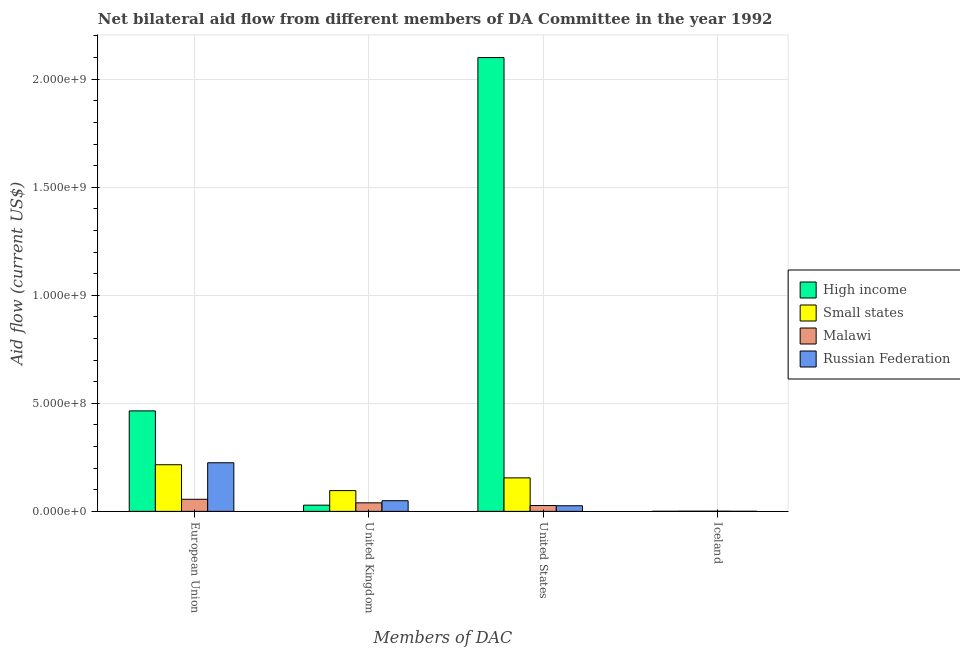How many groups of bars are there?
Keep it short and to the point. 4. Are the number of bars per tick equal to the number of legend labels?
Keep it short and to the point. Yes. What is the label of the 2nd group of bars from the left?
Your response must be concise. United Kingdom. What is the amount of aid given by eu in Malawi?
Offer a terse response. 5.60e+07. Across all countries, what is the maximum amount of aid given by uk?
Keep it short and to the point. 9.61e+07. Across all countries, what is the minimum amount of aid given by eu?
Provide a short and direct response. 5.60e+07. In which country was the amount of aid given by eu minimum?
Offer a terse response. Malawi. What is the total amount of aid given by iceland in the graph?
Ensure brevity in your answer.  2.15e+06. What is the difference between the amount of aid given by us in High income and that in Russian Federation?
Provide a short and direct response. 2.07e+09. What is the difference between the amount of aid given by iceland in High income and the amount of aid given by uk in Small states?
Your response must be concise. -9.58e+07. What is the average amount of aid given by eu per country?
Make the answer very short. 2.40e+08. What is the difference between the amount of aid given by iceland and amount of aid given by eu in Small states?
Offer a terse response. -2.15e+08. What is the ratio of the amount of aid given by iceland in Malawi to that in High income?
Your answer should be compact. 2.5. What is the difference between the highest and the second highest amount of aid given by eu?
Offer a terse response. 2.40e+08. What is the difference between the highest and the lowest amount of aid given by iceland?
Your response must be concise. 5.00e+05. What does the 2nd bar from the left in European Union represents?
Offer a very short reply. Small states. Is it the case that in every country, the sum of the amount of aid given by eu and amount of aid given by uk is greater than the amount of aid given by us?
Your response must be concise. No. What is the difference between two consecutive major ticks on the Y-axis?
Give a very brief answer. 5.00e+08. What is the title of the graph?
Make the answer very short. Net bilateral aid flow from different members of DA Committee in the year 1992. What is the label or title of the X-axis?
Offer a terse response. Members of DAC. What is the Aid flow (current US$) of High income in European Union?
Your response must be concise. 4.65e+08. What is the Aid flow (current US$) of Small states in European Union?
Offer a very short reply. 2.16e+08. What is the Aid flow (current US$) of Malawi in European Union?
Keep it short and to the point. 5.60e+07. What is the Aid flow (current US$) of Russian Federation in European Union?
Give a very brief answer. 2.25e+08. What is the Aid flow (current US$) in High income in United Kingdom?
Keep it short and to the point. 2.87e+07. What is the Aid flow (current US$) in Small states in United Kingdom?
Ensure brevity in your answer.  9.61e+07. What is the Aid flow (current US$) in Malawi in United Kingdom?
Make the answer very short. 3.95e+07. What is the Aid flow (current US$) of Russian Federation in United Kingdom?
Your answer should be compact. 4.93e+07. What is the Aid flow (current US$) in High income in United States?
Make the answer very short. 2.10e+09. What is the Aid flow (current US$) in Small states in United States?
Your answer should be very brief. 1.55e+08. What is the Aid flow (current US$) in Malawi in United States?
Keep it short and to the point. 2.70e+07. What is the Aid flow (current US$) in Russian Federation in United States?
Make the answer very short. 2.60e+07. What is the Aid flow (current US$) in Malawi in Iceland?
Your answer should be compact. 7.50e+05. Across all Members of DAC, what is the maximum Aid flow (current US$) in High income?
Your answer should be very brief. 2.10e+09. Across all Members of DAC, what is the maximum Aid flow (current US$) of Small states?
Make the answer very short. 2.16e+08. Across all Members of DAC, what is the maximum Aid flow (current US$) in Malawi?
Provide a succinct answer. 5.60e+07. Across all Members of DAC, what is the maximum Aid flow (current US$) in Russian Federation?
Provide a succinct answer. 2.25e+08. Across all Members of DAC, what is the minimum Aid flow (current US$) of Malawi?
Provide a succinct answer. 7.50e+05. Across all Members of DAC, what is the minimum Aid flow (current US$) in Russian Federation?
Your answer should be compact. 3.00e+05. What is the total Aid flow (current US$) in High income in the graph?
Provide a short and direct response. 2.59e+09. What is the total Aid flow (current US$) in Small states in the graph?
Provide a succinct answer. 4.68e+08. What is the total Aid flow (current US$) in Malawi in the graph?
Give a very brief answer. 1.23e+08. What is the total Aid flow (current US$) of Russian Federation in the graph?
Offer a very short reply. 3.01e+08. What is the difference between the Aid flow (current US$) of High income in European Union and that in United Kingdom?
Offer a very short reply. 4.36e+08. What is the difference between the Aid flow (current US$) of Small states in European Union and that in United Kingdom?
Offer a terse response. 1.20e+08. What is the difference between the Aid flow (current US$) of Malawi in European Union and that in United Kingdom?
Ensure brevity in your answer.  1.65e+07. What is the difference between the Aid flow (current US$) in Russian Federation in European Union and that in United Kingdom?
Provide a short and direct response. 1.76e+08. What is the difference between the Aid flow (current US$) of High income in European Union and that in United States?
Ensure brevity in your answer.  -1.64e+09. What is the difference between the Aid flow (current US$) of Small states in European Union and that in United States?
Make the answer very short. 6.07e+07. What is the difference between the Aid flow (current US$) in Malawi in European Union and that in United States?
Make the answer very short. 2.90e+07. What is the difference between the Aid flow (current US$) of Russian Federation in European Union and that in United States?
Give a very brief answer. 1.99e+08. What is the difference between the Aid flow (current US$) of High income in European Union and that in Iceland?
Provide a short and direct response. 4.65e+08. What is the difference between the Aid flow (current US$) in Small states in European Union and that in Iceland?
Provide a short and direct response. 2.15e+08. What is the difference between the Aid flow (current US$) in Malawi in European Union and that in Iceland?
Ensure brevity in your answer.  5.52e+07. What is the difference between the Aid flow (current US$) in Russian Federation in European Union and that in Iceland?
Offer a very short reply. 2.25e+08. What is the difference between the Aid flow (current US$) in High income in United Kingdom and that in United States?
Keep it short and to the point. -2.07e+09. What is the difference between the Aid flow (current US$) in Small states in United Kingdom and that in United States?
Provide a succinct answer. -5.89e+07. What is the difference between the Aid flow (current US$) in Malawi in United Kingdom and that in United States?
Your answer should be compact. 1.25e+07. What is the difference between the Aid flow (current US$) of Russian Federation in United Kingdom and that in United States?
Your answer should be very brief. 2.33e+07. What is the difference between the Aid flow (current US$) of High income in United Kingdom and that in Iceland?
Provide a succinct answer. 2.84e+07. What is the difference between the Aid flow (current US$) of Small states in United Kingdom and that in Iceland?
Offer a terse response. 9.53e+07. What is the difference between the Aid flow (current US$) of Malawi in United Kingdom and that in Iceland?
Make the answer very short. 3.87e+07. What is the difference between the Aid flow (current US$) of Russian Federation in United Kingdom and that in Iceland?
Your response must be concise. 4.90e+07. What is the difference between the Aid flow (current US$) in High income in United States and that in Iceland?
Your answer should be very brief. 2.10e+09. What is the difference between the Aid flow (current US$) in Small states in United States and that in Iceland?
Your answer should be compact. 1.54e+08. What is the difference between the Aid flow (current US$) of Malawi in United States and that in Iceland?
Provide a succinct answer. 2.62e+07. What is the difference between the Aid flow (current US$) in Russian Federation in United States and that in Iceland?
Offer a very short reply. 2.57e+07. What is the difference between the Aid flow (current US$) of High income in European Union and the Aid flow (current US$) of Small states in United Kingdom?
Offer a very short reply. 3.69e+08. What is the difference between the Aid flow (current US$) in High income in European Union and the Aid flow (current US$) in Malawi in United Kingdom?
Ensure brevity in your answer.  4.26e+08. What is the difference between the Aid flow (current US$) of High income in European Union and the Aid flow (current US$) of Russian Federation in United Kingdom?
Your answer should be very brief. 4.16e+08. What is the difference between the Aid flow (current US$) in Small states in European Union and the Aid flow (current US$) in Malawi in United Kingdom?
Offer a terse response. 1.76e+08. What is the difference between the Aid flow (current US$) of Small states in European Union and the Aid flow (current US$) of Russian Federation in United Kingdom?
Provide a short and direct response. 1.66e+08. What is the difference between the Aid flow (current US$) in Malawi in European Union and the Aid flow (current US$) in Russian Federation in United Kingdom?
Keep it short and to the point. 6.64e+06. What is the difference between the Aid flow (current US$) in High income in European Union and the Aid flow (current US$) in Small states in United States?
Your answer should be compact. 3.10e+08. What is the difference between the Aid flow (current US$) in High income in European Union and the Aid flow (current US$) in Malawi in United States?
Offer a terse response. 4.38e+08. What is the difference between the Aid flow (current US$) in High income in European Union and the Aid flow (current US$) in Russian Federation in United States?
Provide a short and direct response. 4.39e+08. What is the difference between the Aid flow (current US$) in Small states in European Union and the Aid flow (current US$) in Malawi in United States?
Offer a very short reply. 1.89e+08. What is the difference between the Aid flow (current US$) of Small states in European Union and the Aid flow (current US$) of Russian Federation in United States?
Keep it short and to the point. 1.90e+08. What is the difference between the Aid flow (current US$) in Malawi in European Union and the Aid flow (current US$) in Russian Federation in United States?
Make the answer very short. 3.00e+07. What is the difference between the Aid flow (current US$) in High income in European Union and the Aid flow (current US$) in Small states in Iceland?
Your answer should be compact. 4.64e+08. What is the difference between the Aid flow (current US$) of High income in European Union and the Aid flow (current US$) of Malawi in Iceland?
Your answer should be compact. 4.64e+08. What is the difference between the Aid flow (current US$) in High income in European Union and the Aid flow (current US$) in Russian Federation in Iceland?
Give a very brief answer. 4.65e+08. What is the difference between the Aid flow (current US$) in Small states in European Union and the Aid flow (current US$) in Malawi in Iceland?
Make the answer very short. 2.15e+08. What is the difference between the Aid flow (current US$) in Small states in European Union and the Aid flow (current US$) in Russian Federation in Iceland?
Provide a short and direct response. 2.15e+08. What is the difference between the Aid flow (current US$) in Malawi in European Union and the Aid flow (current US$) in Russian Federation in Iceland?
Your answer should be very brief. 5.57e+07. What is the difference between the Aid flow (current US$) in High income in United Kingdom and the Aid flow (current US$) in Small states in United States?
Offer a terse response. -1.26e+08. What is the difference between the Aid flow (current US$) in High income in United Kingdom and the Aid flow (current US$) in Malawi in United States?
Provide a short and direct response. 1.67e+06. What is the difference between the Aid flow (current US$) of High income in United Kingdom and the Aid flow (current US$) of Russian Federation in United States?
Make the answer very short. 2.67e+06. What is the difference between the Aid flow (current US$) of Small states in United Kingdom and the Aid flow (current US$) of Malawi in United States?
Your answer should be compact. 6.91e+07. What is the difference between the Aid flow (current US$) of Small states in United Kingdom and the Aid flow (current US$) of Russian Federation in United States?
Offer a terse response. 7.01e+07. What is the difference between the Aid flow (current US$) of Malawi in United Kingdom and the Aid flow (current US$) of Russian Federation in United States?
Provide a succinct answer. 1.35e+07. What is the difference between the Aid flow (current US$) of High income in United Kingdom and the Aid flow (current US$) of Small states in Iceland?
Provide a succinct answer. 2.79e+07. What is the difference between the Aid flow (current US$) in High income in United Kingdom and the Aid flow (current US$) in Malawi in Iceland?
Offer a very short reply. 2.79e+07. What is the difference between the Aid flow (current US$) of High income in United Kingdom and the Aid flow (current US$) of Russian Federation in Iceland?
Provide a succinct answer. 2.84e+07. What is the difference between the Aid flow (current US$) in Small states in United Kingdom and the Aid flow (current US$) in Malawi in Iceland?
Provide a succinct answer. 9.54e+07. What is the difference between the Aid flow (current US$) of Small states in United Kingdom and the Aid flow (current US$) of Russian Federation in Iceland?
Ensure brevity in your answer.  9.58e+07. What is the difference between the Aid flow (current US$) of Malawi in United Kingdom and the Aid flow (current US$) of Russian Federation in Iceland?
Your response must be concise. 3.92e+07. What is the difference between the Aid flow (current US$) of High income in United States and the Aid flow (current US$) of Small states in Iceland?
Keep it short and to the point. 2.10e+09. What is the difference between the Aid flow (current US$) of High income in United States and the Aid flow (current US$) of Malawi in Iceland?
Provide a short and direct response. 2.10e+09. What is the difference between the Aid flow (current US$) of High income in United States and the Aid flow (current US$) of Russian Federation in Iceland?
Give a very brief answer. 2.10e+09. What is the difference between the Aid flow (current US$) in Small states in United States and the Aid flow (current US$) in Malawi in Iceland?
Offer a terse response. 1.54e+08. What is the difference between the Aid flow (current US$) in Small states in United States and the Aid flow (current US$) in Russian Federation in Iceland?
Make the answer very short. 1.55e+08. What is the difference between the Aid flow (current US$) in Malawi in United States and the Aid flow (current US$) in Russian Federation in Iceland?
Your answer should be compact. 2.67e+07. What is the average Aid flow (current US$) of High income per Members of DAC?
Your answer should be very brief. 6.48e+08. What is the average Aid flow (current US$) in Small states per Members of DAC?
Ensure brevity in your answer.  1.17e+08. What is the average Aid flow (current US$) in Malawi per Members of DAC?
Provide a succinct answer. 3.08e+07. What is the average Aid flow (current US$) of Russian Federation per Members of DAC?
Your answer should be very brief. 7.51e+07. What is the difference between the Aid flow (current US$) of High income and Aid flow (current US$) of Small states in European Union?
Keep it short and to the point. 2.49e+08. What is the difference between the Aid flow (current US$) of High income and Aid flow (current US$) of Malawi in European Union?
Your answer should be compact. 4.09e+08. What is the difference between the Aid flow (current US$) of High income and Aid flow (current US$) of Russian Federation in European Union?
Make the answer very short. 2.40e+08. What is the difference between the Aid flow (current US$) in Small states and Aid flow (current US$) in Malawi in European Union?
Ensure brevity in your answer.  1.60e+08. What is the difference between the Aid flow (current US$) in Small states and Aid flow (current US$) in Russian Federation in European Union?
Offer a very short reply. -9.24e+06. What is the difference between the Aid flow (current US$) in Malawi and Aid flow (current US$) in Russian Federation in European Union?
Offer a very short reply. -1.69e+08. What is the difference between the Aid flow (current US$) in High income and Aid flow (current US$) in Small states in United Kingdom?
Provide a short and direct response. -6.74e+07. What is the difference between the Aid flow (current US$) of High income and Aid flow (current US$) of Malawi in United Kingdom?
Your answer should be very brief. -1.08e+07. What is the difference between the Aid flow (current US$) of High income and Aid flow (current US$) of Russian Federation in United Kingdom?
Your answer should be very brief. -2.06e+07. What is the difference between the Aid flow (current US$) in Small states and Aid flow (current US$) in Malawi in United Kingdom?
Your answer should be very brief. 5.66e+07. What is the difference between the Aid flow (current US$) of Small states and Aid flow (current US$) of Russian Federation in United Kingdom?
Your answer should be very brief. 4.68e+07. What is the difference between the Aid flow (current US$) in Malawi and Aid flow (current US$) in Russian Federation in United Kingdom?
Provide a short and direct response. -9.86e+06. What is the difference between the Aid flow (current US$) in High income and Aid flow (current US$) in Small states in United States?
Your answer should be very brief. 1.94e+09. What is the difference between the Aid flow (current US$) of High income and Aid flow (current US$) of Malawi in United States?
Ensure brevity in your answer.  2.07e+09. What is the difference between the Aid flow (current US$) of High income and Aid flow (current US$) of Russian Federation in United States?
Provide a short and direct response. 2.07e+09. What is the difference between the Aid flow (current US$) in Small states and Aid flow (current US$) in Malawi in United States?
Ensure brevity in your answer.  1.28e+08. What is the difference between the Aid flow (current US$) in Small states and Aid flow (current US$) in Russian Federation in United States?
Your response must be concise. 1.29e+08. What is the difference between the Aid flow (current US$) in Malawi and Aid flow (current US$) in Russian Federation in United States?
Your answer should be compact. 1.00e+06. What is the difference between the Aid flow (current US$) of High income and Aid flow (current US$) of Small states in Iceland?
Keep it short and to the point. -5.00e+05. What is the difference between the Aid flow (current US$) in High income and Aid flow (current US$) in Malawi in Iceland?
Provide a short and direct response. -4.50e+05. What is the difference between the Aid flow (current US$) in High income and Aid flow (current US$) in Russian Federation in Iceland?
Offer a very short reply. 0. What is the difference between the Aid flow (current US$) of Small states and Aid flow (current US$) of Malawi in Iceland?
Ensure brevity in your answer.  5.00e+04. What is the difference between the Aid flow (current US$) in Malawi and Aid flow (current US$) in Russian Federation in Iceland?
Make the answer very short. 4.50e+05. What is the ratio of the Aid flow (current US$) in High income in European Union to that in United Kingdom?
Your answer should be very brief. 16.22. What is the ratio of the Aid flow (current US$) of Small states in European Union to that in United Kingdom?
Your answer should be compact. 2.24. What is the ratio of the Aid flow (current US$) of Malawi in European Union to that in United Kingdom?
Offer a terse response. 1.42. What is the ratio of the Aid flow (current US$) in Russian Federation in European Union to that in United Kingdom?
Provide a succinct answer. 4.56. What is the ratio of the Aid flow (current US$) in High income in European Union to that in United States?
Provide a short and direct response. 0.22. What is the ratio of the Aid flow (current US$) of Small states in European Union to that in United States?
Provide a short and direct response. 1.39. What is the ratio of the Aid flow (current US$) of Malawi in European Union to that in United States?
Make the answer very short. 2.07. What is the ratio of the Aid flow (current US$) in Russian Federation in European Union to that in United States?
Keep it short and to the point. 8.65. What is the ratio of the Aid flow (current US$) in High income in European Union to that in Iceland?
Keep it short and to the point. 1549.97. What is the ratio of the Aid flow (current US$) in Small states in European Union to that in Iceland?
Offer a terse response. 269.64. What is the ratio of the Aid flow (current US$) in Malawi in European Union to that in Iceland?
Make the answer very short. 74.61. What is the ratio of the Aid flow (current US$) of Russian Federation in European Union to that in Iceland?
Provide a short and direct response. 749.83. What is the ratio of the Aid flow (current US$) of High income in United Kingdom to that in United States?
Your answer should be very brief. 0.01. What is the ratio of the Aid flow (current US$) of Small states in United Kingdom to that in United States?
Offer a terse response. 0.62. What is the ratio of the Aid flow (current US$) of Malawi in United Kingdom to that in United States?
Keep it short and to the point. 1.46. What is the ratio of the Aid flow (current US$) in Russian Federation in United Kingdom to that in United States?
Your response must be concise. 1.9. What is the ratio of the Aid flow (current US$) of High income in United Kingdom to that in Iceland?
Offer a very short reply. 95.57. What is the ratio of the Aid flow (current US$) of Small states in United Kingdom to that in Iceland?
Ensure brevity in your answer.  120.14. What is the ratio of the Aid flow (current US$) of Malawi in United Kingdom to that in Iceland?
Ensure brevity in your answer.  52.61. What is the ratio of the Aid flow (current US$) in Russian Federation in United Kingdom to that in Iceland?
Give a very brief answer. 164.4. What is the ratio of the Aid flow (current US$) in High income in United States to that in Iceland?
Offer a very short reply. 7000. What is the ratio of the Aid flow (current US$) of Small states in United States to that in Iceland?
Give a very brief answer. 193.75. What is the ratio of the Aid flow (current US$) of Russian Federation in United States to that in Iceland?
Offer a terse response. 86.67. What is the difference between the highest and the second highest Aid flow (current US$) in High income?
Your response must be concise. 1.64e+09. What is the difference between the highest and the second highest Aid flow (current US$) in Small states?
Ensure brevity in your answer.  6.07e+07. What is the difference between the highest and the second highest Aid flow (current US$) of Malawi?
Keep it short and to the point. 1.65e+07. What is the difference between the highest and the second highest Aid flow (current US$) of Russian Federation?
Your answer should be very brief. 1.76e+08. What is the difference between the highest and the lowest Aid flow (current US$) in High income?
Your answer should be very brief. 2.10e+09. What is the difference between the highest and the lowest Aid flow (current US$) of Small states?
Make the answer very short. 2.15e+08. What is the difference between the highest and the lowest Aid flow (current US$) of Malawi?
Make the answer very short. 5.52e+07. What is the difference between the highest and the lowest Aid flow (current US$) of Russian Federation?
Give a very brief answer. 2.25e+08. 